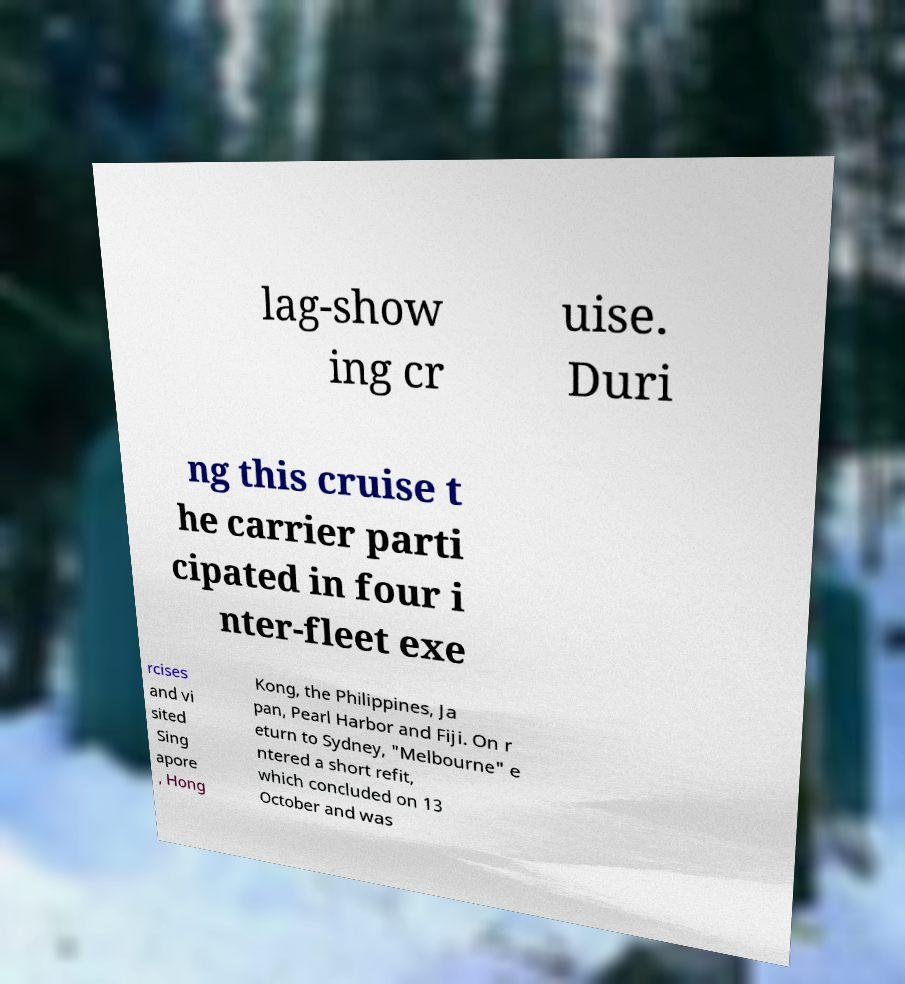I need the written content from this picture converted into text. Can you do that? lag-show ing cr uise. Duri ng this cruise t he carrier parti cipated in four i nter-fleet exe rcises and vi sited Sing apore , Hong Kong, the Philippines, Ja pan, Pearl Harbor and Fiji. On r eturn to Sydney, "Melbourne" e ntered a short refit, which concluded on 13 October and was 